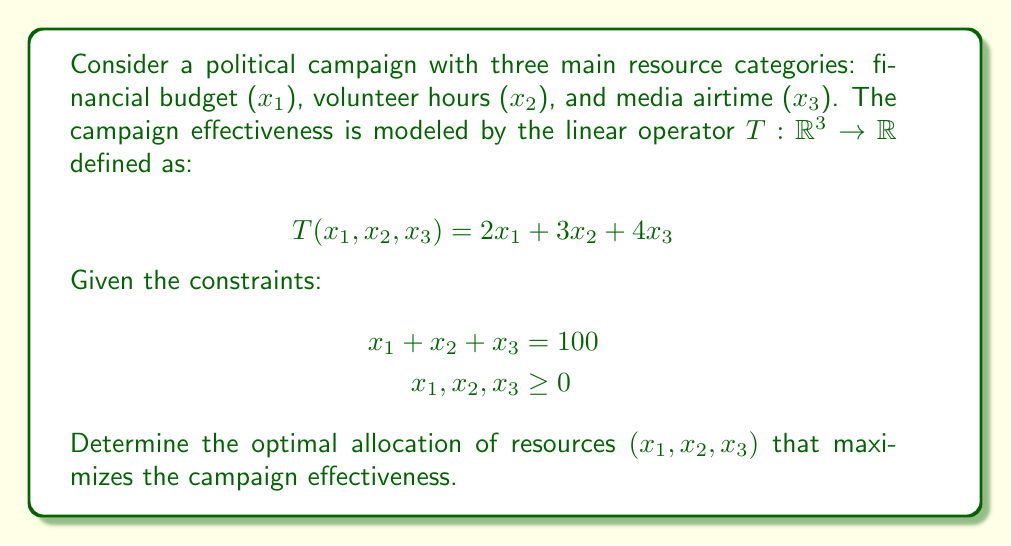What is the answer to this math problem? To solve this optimization problem, we can use the method of Lagrange multipliers:

1) Define the Lagrangian function:
   $$L(x_1, x_2, x_3, \lambda) = 2x_1 + 3x_2 + 4x_3 - \lambda(x_1 + x_2 + x_3 - 100)$$

2) Calculate partial derivatives and set them to zero:
   $$\begin{align*}
   \frac{\partial L}{\partial x_1} &= 2 - \lambda = 0 \\
   \frac{\partial L}{\partial x_2} &= 3 - \lambda = 0 \\
   \frac{\partial L}{\partial x_3} &= 4 - \lambda = 0 \\
   \frac{\partial L}{\partial \lambda} &= x_1 + x_2 + x_3 - 100 = 0
   \end{align*}$$

3) From these equations, we can deduce:
   $$\lambda = 2 = 3 = 4$$

   This is impossible, indicating that the optimal solution lies on the boundary of the feasible region.

4) Given the constraints $x_1, x_2, x_3 \geq 0$ and the objective function coefficients (2, 3, 4), the optimal solution is to allocate all resources to $x_3$ (media airtime), which has the highest coefficient.

5) Therefore, the optimal allocation is:
   $$x_1 = 0, x_2 = 0, x_3 = 100$$

6) The maximum campaign effectiveness is:
   $$T(0, 0, 100) = 2(0) + 3(0) + 4(100) = 400$$
Answer: The optimal allocation of resources is $(x_1, x_2, x_3) = (0, 0, 100)$, resulting in a maximum campaign effectiveness of 400. 